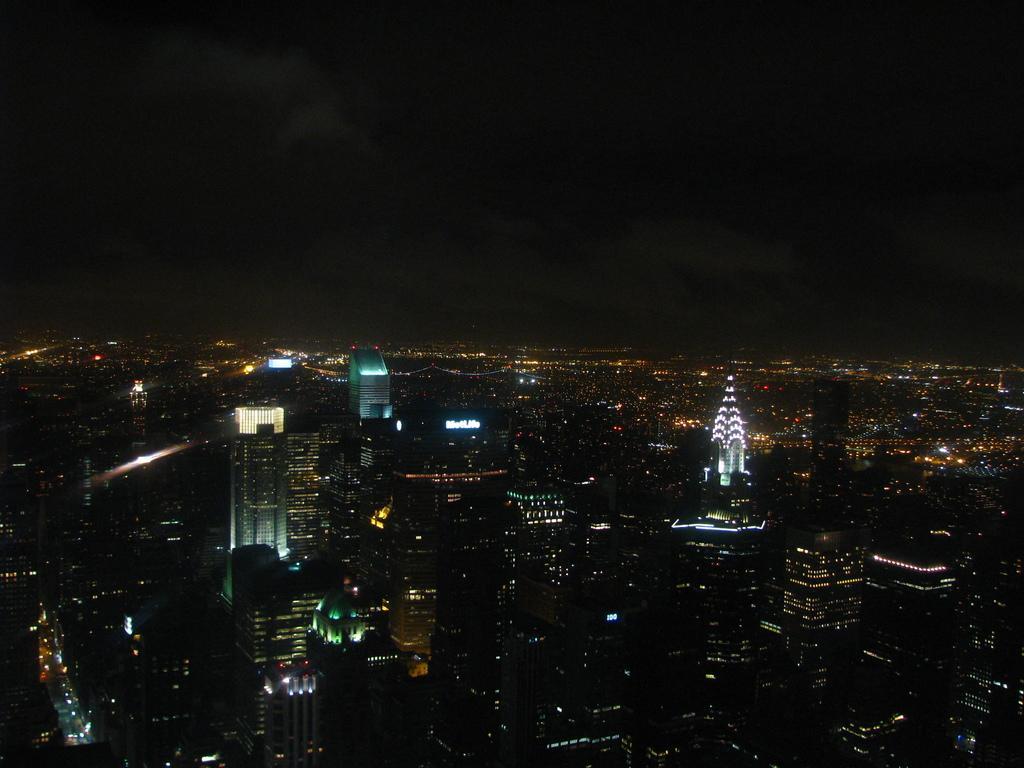In one or two sentences, can you explain what this image depicts? This is a dark image, we can see some lights in the buildings. 